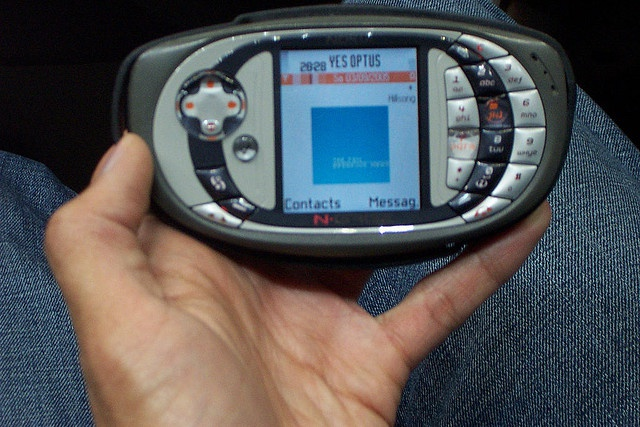Describe the objects in this image and their specific colors. I can see cell phone in black, darkgray, gray, and lightblue tones and people in black, gray, and tan tones in this image. 